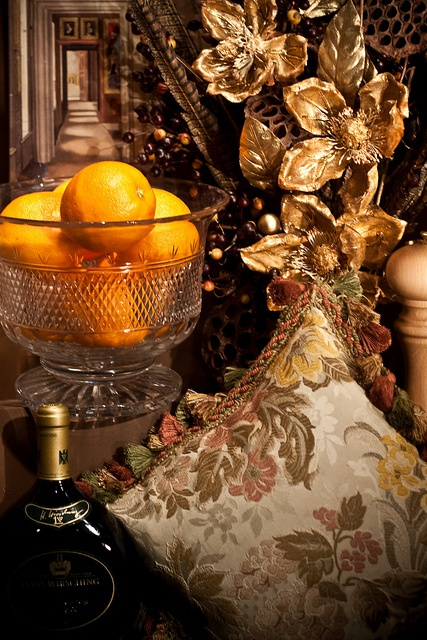Describe the objects in this image and their specific colors. I can see bowl in black, maroon, orange, red, and brown tones, bottle in black, maroon, and olive tones, orange in black, red, maroon, and brown tones, orange in black, orange, gold, and red tones, and orange in black, orange, red, gold, and maroon tones in this image. 